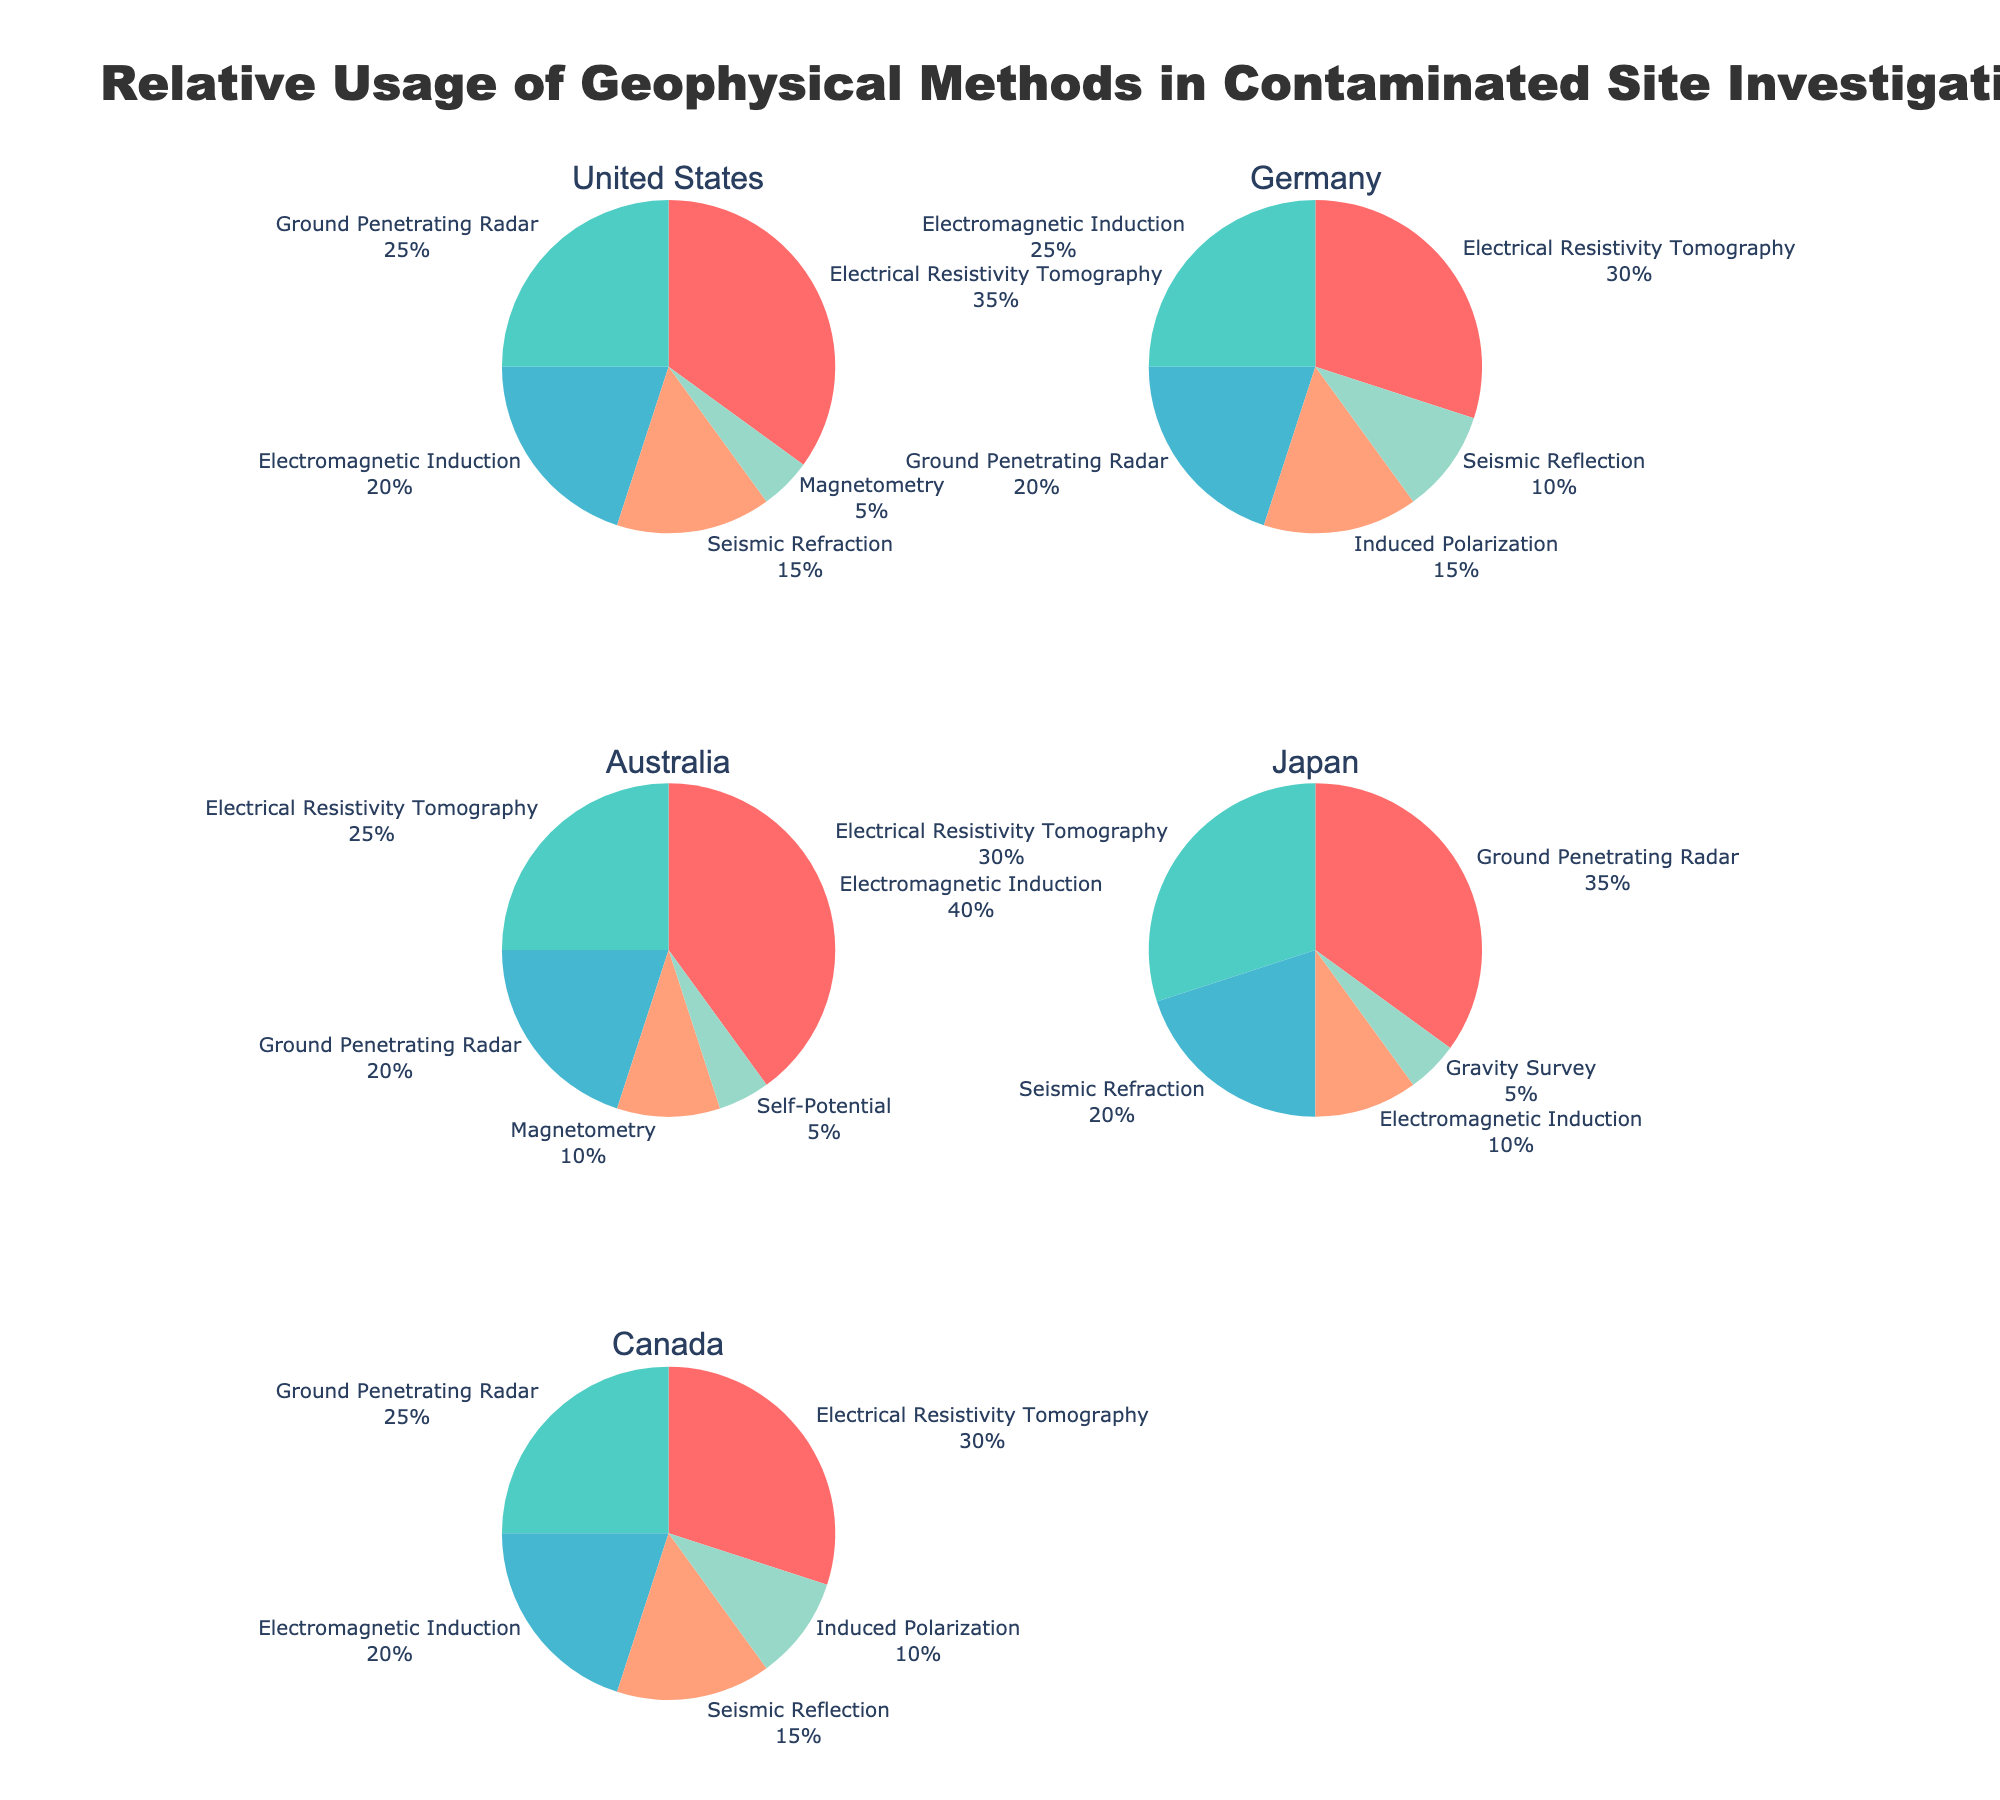What is the most commonly used geophysical method in the United States? The largest slice of the pie chart for the United States represents the method with the highest usage percentage. Electrical Resistivity Tomography occupies the largest slice at 35%.
Answer: Electrical Resistivity Tomography Which country utilizes Electromagnetic Induction the most? Comparing the sizes of the slices representing Electromagnetic Induction in each country's pie chart, Australia has the largest slice for this method at 40%.
Answer: Australia How does the usage of Ground Penetrating Radar in Japan compare to that in Germany? Japan has a 35% usage of Ground Penetrating Radar, while Germany has 20%. Japan uses Ground Penetrating Radar more frequently than Germany.
Answer: Japan uses it more frequently What percentage of the geophysical methods used in Canada are Ground Penetrating Radar and Electromagnetic Induction? Adding the percentages for Ground Penetrating Radar (25%) and Electromagnetic Induction (20%) in Canada: 25% + 20% = 45%.
Answer: 45% Which country has the smallest representation for Magnetometry usage, and what is the percentage? By comparing the slices for Magnetometry, the United States has the smallest representation at 5%.
Answer: United States, 5% What is the total percentage of Electrical Resistivity Tomography usage in all the countries combined? Summing up the percentages for Electrical Resistivity Tomography in each country: United States (35%) + Germany (30%) + Australia (25%) + Japan (30%) + Canada (30%) = 150%.
Answer: 150% What proportion of Germany's geophysical methods are either Induced Polarization or Seismic Reflection? Adding the percentages for Induced Polarization (15%) and Seismic Reflection (10%) in Germany: 15% + 10% = 25%.
Answer: 25% Which geophysical method is used exclusively in Australia and not represented in other countries? By observing all the slices, Self-Potential is only represented in Australia's pie chart at 5% and not in the others.
Answer: Self-Potential How does the usage of Seismic Refraction in Japan compare to its usage in the United States? Japan has a 20% usage of Seismic Refraction while the United States has 15%, indicating that Japan uses this method more.
Answer: Japan uses it more What is the average usage percentage of Ground Penetrating Radar across all countries? Calculating the average for Ground Penetrating Radar usage: (25% (United States) + 20% (Germany) + 20% (Australia) + 35% (Japan) + 25% (Canada)) / 5 = 25%.
Answer: 25% 